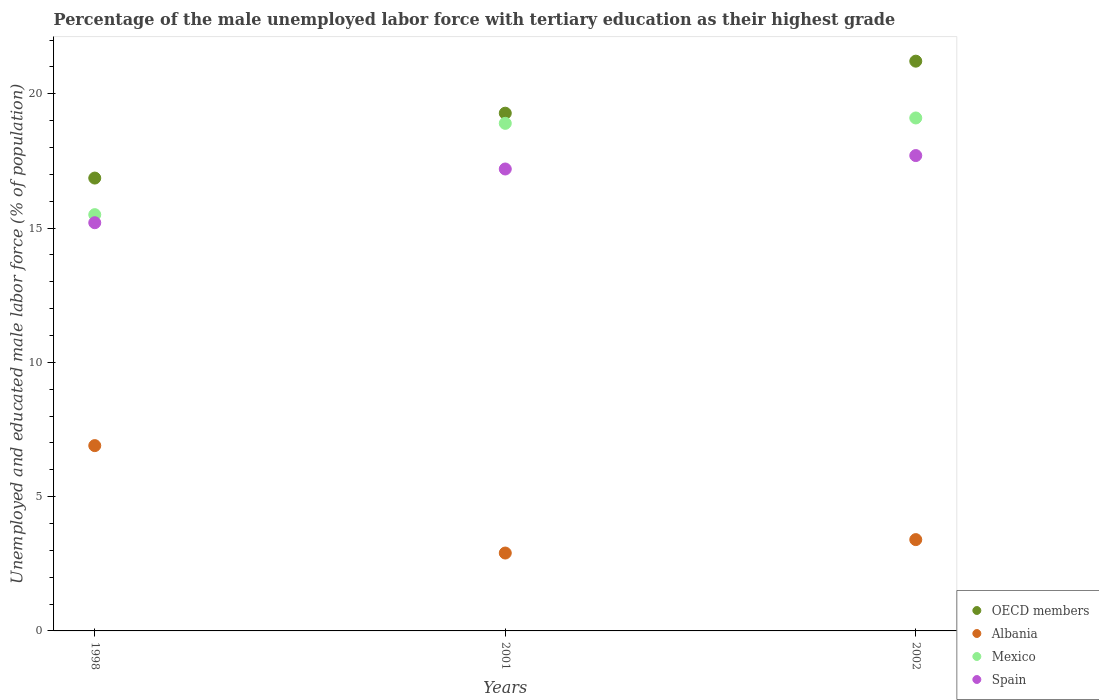How many different coloured dotlines are there?
Your answer should be very brief. 4. What is the percentage of the unemployed male labor force with tertiary education in OECD members in 1998?
Offer a very short reply. 16.86. Across all years, what is the maximum percentage of the unemployed male labor force with tertiary education in Spain?
Offer a very short reply. 17.7. Across all years, what is the minimum percentage of the unemployed male labor force with tertiary education in Albania?
Your answer should be compact. 2.9. In which year was the percentage of the unemployed male labor force with tertiary education in Mexico maximum?
Your response must be concise. 2002. In which year was the percentage of the unemployed male labor force with tertiary education in Albania minimum?
Make the answer very short. 2001. What is the total percentage of the unemployed male labor force with tertiary education in Mexico in the graph?
Your answer should be very brief. 53.5. What is the difference between the percentage of the unemployed male labor force with tertiary education in Spain in 1998 and that in 2002?
Give a very brief answer. -2.5. What is the difference between the percentage of the unemployed male labor force with tertiary education in Mexico in 1998 and the percentage of the unemployed male labor force with tertiary education in Spain in 2001?
Provide a succinct answer. -1.7. What is the average percentage of the unemployed male labor force with tertiary education in OECD members per year?
Your answer should be very brief. 19.12. In the year 2002, what is the difference between the percentage of the unemployed male labor force with tertiary education in Mexico and percentage of the unemployed male labor force with tertiary education in Spain?
Ensure brevity in your answer.  1.4. What is the ratio of the percentage of the unemployed male labor force with tertiary education in Albania in 1998 to that in 2002?
Provide a short and direct response. 2.03. Is the percentage of the unemployed male labor force with tertiary education in Mexico in 2001 less than that in 2002?
Ensure brevity in your answer.  Yes. What is the difference between the highest and the second highest percentage of the unemployed male labor force with tertiary education in Spain?
Provide a short and direct response. 0.5. What is the difference between the highest and the lowest percentage of the unemployed male labor force with tertiary education in Mexico?
Keep it short and to the point. 3.6. Is it the case that in every year, the sum of the percentage of the unemployed male labor force with tertiary education in Albania and percentage of the unemployed male labor force with tertiary education in Mexico  is greater than the sum of percentage of the unemployed male labor force with tertiary education in OECD members and percentage of the unemployed male labor force with tertiary education in Spain?
Make the answer very short. No. Is it the case that in every year, the sum of the percentage of the unemployed male labor force with tertiary education in OECD members and percentage of the unemployed male labor force with tertiary education in Albania  is greater than the percentage of the unemployed male labor force with tertiary education in Mexico?
Provide a succinct answer. Yes. Does the percentage of the unemployed male labor force with tertiary education in Albania monotonically increase over the years?
Your answer should be compact. No. Is the percentage of the unemployed male labor force with tertiary education in Albania strictly greater than the percentage of the unemployed male labor force with tertiary education in OECD members over the years?
Keep it short and to the point. No. Is the percentage of the unemployed male labor force with tertiary education in Mexico strictly less than the percentage of the unemployed male labor force with tertiary education in OECD members over the years?
Offer a very short reply. Yes. Where does the legend appear in the graph?
Your answer should be very brief. Bottom right. How are the legend labels stacked?
Your answer should be very brief. Vertical. What is the title of the graph?
Make the answer very short. Percentage of the male unemployed labor force with tertiary education as their highest grade. Does "Cyprus" appear as one of the legend labels in the graph?
Offer a terse response. No. What is the label or title of the Y-axis?
Provide a succinct answer. Unemployed and educated male labor force (% of population). What is the Unemployed and educated male labor force (% of population) in OECD members in 1998?
Your answer should be compact. 16.86. What is the Unemployed and educated male labor force (% of population) in Albania in 1998?
Make the answer very short. 6.9. What is the Unemployed and educated male labor force (% of population) in Mexico in 1998?
Keep it short and to the point. 15.5. What is the Unemployed and educated male labor force (% of population) in Spain in 1998?
Provide a short and direct response. 15.2. What is the Unemployed and educated male labor force (% of population) in OECD members in 2001?
Offer a very short reply. 19.28. What is the Unemployed and educated male labor force (% of population) in Albania in 2001?
Your answer should be compact. 2.9. What is the Unemployed and educated male labor force (% of population) of Mexico in 2001?
Keep it short and to the point. 18.9. What is the Unemployed and educated male labor force (% of population) in Spain in 2001?
Give a very brief answer. 17.2. What is the Unemployed and educated male labor force (% of population) of OECD members in 2002?
Ensure brevity in your answer.  21.21. What is the Unemployed and educated male labor force (% of population) in Albania in 2002?
Your answer should be compact. 3.4. What is the Unemployed and educated male labor force (% of population) of Mexico in 2002?
Offer a terse response. 19.1. What is the Unemployed and educated male labor force (% of population) in Spain in 2002?
Offer a very short reply. 17.7. Across all years, what is the maximum Unemployed and educated male labor force (% of population) of OECD members?
Your response must be concise. 21.21. Across all years, what is the maximum Unemployed and educated male labor force (% of population) of Albania?
Provide a succinct answer. 6.9. Across all years, what is the maximum Unemployed and educated male labor force (% of population) in Mexico?
Offer a terse response. 19.1. Across all years, what is the maximum Unemployed and educated male labor force (% of population) of Spain?
Provide a short and direct response. 17.7. Across all years, what is the minimum Unemployed and educated male labor force (% of population) in OECD members?
Offer a very short reply. 16.86. Across all years, what is the minimum Unemployed and educated male labor force (% of population) of Albania?
Offer a very short reply. 2.9. Across all years, what is the minimum Unemployed and educated male labor force (% of population) in Spain?
Keep it short and to the point. 15.2. What is the total Unemployed and educated male labor force (% of population) in OECD members in the graph?
Give a very brief answer. 57.35. What is the total Unemployed and educated male labor force (% of population) in Albania in the graph?
Ensure brevity in your answer.  13.2. What is the total Unemployed and educated male labor force (% of population) in Mexico in the graph?
Provide a short and direct response. 53.5. What is the total Unemployed and educated male labor force (% of population) in Spain in the graph?
Ensure brevity in your answer.  50.1. What is the difference between the Unemployed and educated male labor force (% of population) of OECD members in 1998 and that in 2001?
Make the answer very short. -2.42. What is the difference between the Unemployed and educated male labor force (% of population) in OECD members in 1998 and that in 2002?
Your answer should be compact. -4.35. What is the difference between the Unemployed and educated male labor force (% of population) of Spain in 1998 and that in 2002?
Give a very brief answer. -2.5. What is the difference between the Unemployed and educated male labor force (% of population) of OECD members in 2001 and that in 2002?
Your response must be concise. -1.94. What is the difference between the Unemployed and educated male labor force (% of population) of OECD members in 1998 and the Unemployed and educated male labor force (% of population) of Albania in 2001?
Provide a succinct answer. 13.96. What is the difference between the Unemployed and educated male labor force (% of population) in OECD members in 1998 and the Unemployed and educated male labor force (% of population) in Mexico in 2001?
Give a very brief answer. -2.04. What is the difference between the Unemployed and educated male labor force (% of population) in OECD members in 1998 and the Unemployed and educated male labor force (% of population) in Spain in 2001?
Give a very brief answer. -0.34. What is the difference between the Unemployed and educated male labor force (% of population) of Albania in 1998 and the Unemployed and educated male labor force (% of population) of Mexico in 2001?
Offer a terse response. -12. What is the difference between the Unemployed and educated male labor force (% of population) of Albania in 1998 and the Unemployed and educated male labor force (% of population) of Spain in 2001?
Provide a short and direct response. -10.3. What is the difference between the Unemployed and educated male labor force (% of population) in Mexico in 1998 and the Unemployed and educated male labor force (% of population) in Spain in 2001?
Offer a very short reply. -1.7. What is the difference between the Unemployed and educated male labor force (% of population) of OECD members in 1998 and the Unemployed and educated male labor force (% of population) of Albania in 2002?
Give a very brief answer. 13.46. What is the difference between the Unemployed and educated male labor force (% of population) of OECD members in 1998 and the Unemployed and educated male labor force (% of population) of Mexico in 2002?
Offer a terse response. -2.24. What is the difference between the Unemployed and educated male labor force (% of population) of OECD members in 1998 and the Unemployed and educated male labor force (% of population) of Spain in 2002?
Offer a very short reply. -0.84. What is the difference between the Unemployed and educated male labor force (% of population) in Mexico in 1998 and the Unemployed and educated male labor force (% of population) in Spain in 2002?
Offer a terse response. -2.2. What is the difference between the Unemployed and educated male labor force (% of population) in OECD members in 2001 and the Unemployed and educated male labor force (% of population) in Albania in 2002?
Provide a succinct answer. 15.88. What is the difference between the Unemployed and educated male labor force (% of population) in OECD members in 2001 and the Unemployed and educated male labor force (% of population) in Mexico in 2002?
Your answer should be compact. 0.18. What is the difference between the Unemployed and educated male labor force (% of population) in OECD members in 2001 and the Unemployed and educated male labor force (% of population) in Spain in 2002?
Give a very brief answer. 1.58. What is the difference between the Unemployed and educated male labor force (% of population) of Albania in 2001 and the Unemployed and educated male labor force (% of population) of Mexico in 2002?
Make the answer very short. -16.2. What is the difference between the Unemployed and educated male labor force (% of population) of Albania in 2001 and the Unemployed and educated male labor force (% of population) of Spain in 2002?
Provide a succinct answer. -14.8. What is the difference between the Unemployed and educated male labor force (% of population) in Mexico in 2001 and the Unemployed and educated male labor force (% of population) in Spain in 2002?
Your answer should be compact. 1.2. What is the average Unemployed and educated male labor force (% of population) in OECD members per year?
Provide a short and direct response. 19.12. What is the average Unemployed and educated male labor force (% of population) in Albania per year?
Give a very brief answer. 4.4. What is the average Unemployed and educated male labor force (% of population) of Mexico per year?
Your response must be concise. 17.83. In the year 1998, what is the difference between the Unemployed and educated male labor force (% of population) of OECD members and Unemployed and educated male labor force (% of population) of Albania?
Provide a succinct answer. 9.96. In the year 1998, what is the difference between the Unemployed and educated male labor force (% of population) in OECD members and Unemployed and educated male labor force (% of population) in Mexico?
Offer a very short reply. 1.36. In the year 1998, what is the difference between the Unemployed and educated male labor force (% of population) of OECD members and Unemployed and educated male labor force (% of population) of Spain?
Your answer should be compact. 1.66. In the year 1998, what is the difference between the Unemployed and educated male labor force (% of population) of Albania and Unemployed and educated male labor force (% of population) of Spain?
Ensure brevity in your answer.  -8.3. In the year 1998, what is the difference between the Unemployed and educated male labor force (% of population) of Mexico and Unemployed and educated male labor force (% of population) of Spain?
Provide a succinct answer. 0.3. In the year 2001, what is the difference between the Unemployed and educated male labor force (% of population) in OECD members and Unemployed and educated male labor force (% of population) in Albania?
Keep it short and to the point. 16.38. In the year 2001, what is the difference between the Unemployed and educated male labor force (% of population) of OECD members and Unemployed and educated male labor force (% of population) of Mexico?
Give a very brief answer. 0.38. In the year 2001, what is the difference between the Unemployed and educated male labor force (% of population) of OECD members and Unemployed and educated male labor force (% of population) of Spain?
Your response must be concise. 2.08. In the year 2001, what is the difference between the Unemployed and educated male labor force (% of population) in Albania and Unemployed and educated male labor force (% of population) in Spain?
Your answer should be very brief. -14.3. In the year 2001, what is the difference between the Unemployed and educated male labor force (% of population) of Mexico and Unemployed and educated male labor force (% of population) of Spain?
Make the answer very short. 1.7. In the year 2002, what is the difference between the Unemployed and educated male labor force (% of population) in OECD members and Unemployed and educated male labor force (% of population) in Albania?
Provide a short and direct response. 17.81. In the year 2002, what is the difference between the Unemployed and educated male labor force (% of population) of OECD members and Unemployed and educated male labor force (% of population) of Mexico?
Your answer should be compact. 2.11. In the year 2002, what is the difference between the Unemployed and educated male labor force (% of population) in OECD members and Unemployed and educated male labor force (% of population) in Spain?
Your response must be concise. 3.51. In the year 2002, what is the difference between the Unemployed and educated male labor force (% of population) of Albania and Unemployed and educated male labor force (% of population) of Mexico?
Provide a short and direct response. -15.7. In the year 2002, what is the difference between the Unemployed and educated male labor force (% of population) of Albania and Unemployed and educated male labor force (% of population) of Spain?
Provide a short and direct response. -14.3. What is the ratio of the Unemployed and educated male labor force (% of population) in OECD members in 1998 to that in 2001?
Your answer should be compact. 0.87. What is the ratio of the Unemployed and educated male labor force (% of population) in Albania in 1998 to that in 2001?
Make the answer very short. 2.38. What is the ratio of the Unemployed and educated male labor force (% of population) of Mexico in 1998 to that in 2001?
Your response must be concise. 0.82. What is the ratio of the Unemployed and educated male labor force (% of population) of Spain in 1998 to that in 2001?
Keep it short and to the point. 0.88. What is the ratio of the Unemployed and educated male labor force (% of population) in OECD members in 1998 to that in 2002?
Your answer should be very brief. 0.79. What is the ratio of the Unemployed and educated male labor force (% of population) of Albania in 1998 to that in 2002?
Your answer should be very brief. 2.03. What is the ratio of the Unemployed and educated male labor force (% of population) of Mexico in 1998 to that in 2002?
Offer a terse response. 0.81. What is the ratio of the Unemployed and educated male labor force (% of population) in Spain in 1998 to that in 2002?
Your response must be concise. 0.86. What is the ratio of the Unemployed and educated male labor force (% of population) in OECD members in 2001 to that in 2002?
Keep it short and to the point. 0.91. What is the ratio of the Unemployed and educated male labor force (% of population) in Albania in 2001 to that in 2002?
Make the answer very short. 0.85. What is the ratio of the Unemployed and educated male labor force (% of population) of Spain in 2001 to that in 2002?
Provide a succinct answer. 0.97. What is the difference between the highest and the second highest Unemployed and educated male labor force (% of population) of OECD members?
Provide a short and direct response. 1.94. What is the difference between the highest and the second highest Unemployed and educated male labor force (% of population) of Albania?
Provide a short and direct response. 3.5. What is the difference between the highest and the second highest Unemployed and educated male labor force (% of population) in Spain?
Offer a terse response. 0.5. What is the difference between the highest and the lowest Unemployed and educated male labor force (% of population) of OECD members?
Keep it short and to the point. 4.35. 